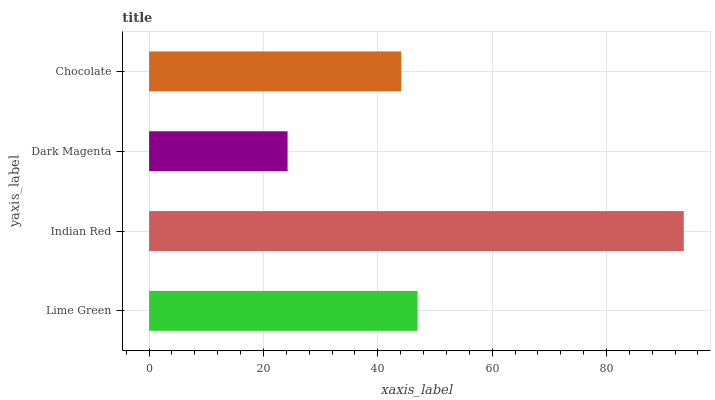Is Dark Magenta the minimum?
Answer yes or no. Yes. Is Indian Red the maximum?
Answer yes or no. Yes. Is Indian Red the minimum?
Answer yes or no. No. Is Dark Magenta the maximum?
Answer yes or no. No. Is Indian Red greater than Dark Magenta?
Answer yes or no. Yes. Is Dark Magenta less than Indian Red?
Answer yes or no. Yes. Is Dark Magenta greater than Indian Red?
Answer yes or no. No. Is Indian Red less than Dark Magenta?
Answer yes or no. No. Is Lime Green the high median?
Answer yes or no. Yes. Is Chocolate the low median?
Answer yes or no. Yes. Is Indian Red the high median?
Answer yes or no. No. Is Indian Red the low median?
Answer yes or no. No. 